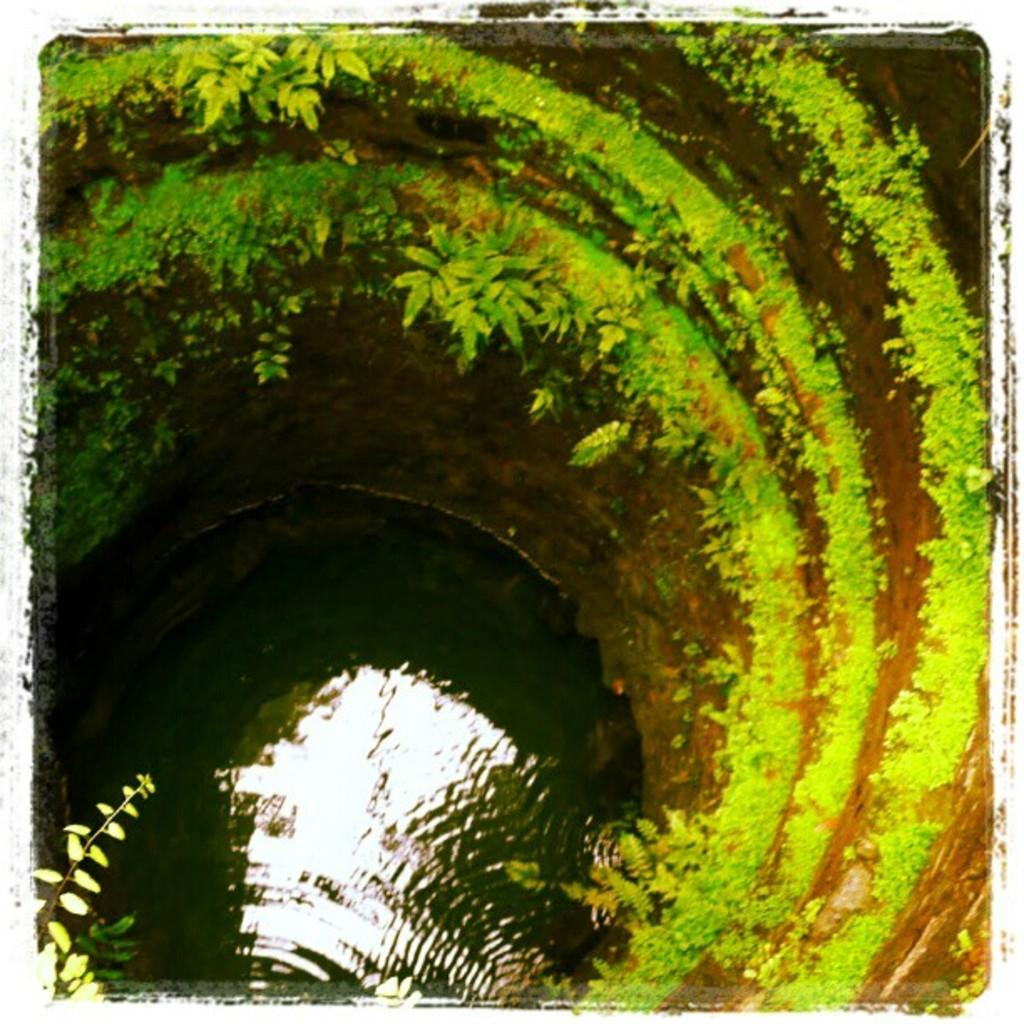What is the main subject of the image? The main subject of the image is a well. What can be seen on the wall of the well? There is greenery on the wall of the well. What is at the bottom of the well? There is water at the bottom of the well. How many sisters are standing next to the well in the image? There are no sisters present in the image; it only depicts a well with greenery on the wall and water at the bottom. 